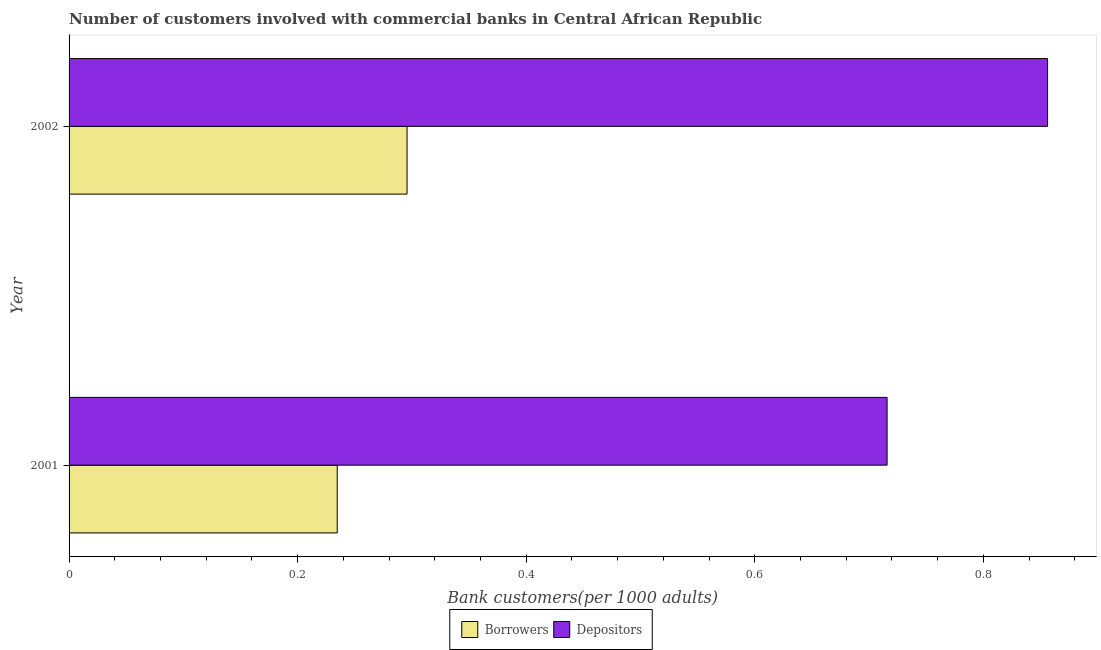Are the number of bars per tick equal to the number of legend labels?
Make the answer very short. Yes. How many bars are there on the 2nd tick from the bottom?
Ensure brevity in your answer.  2. What is the label of the 1st group of bars from the top?
Your response must be concise. 2002. What is the number of borrowers in 2002?
Make the answer very short. 0.3. Across all years, what is the maximum number of borrowers?
Your answer should be compact. 0.3. Across all years, what is the minimum number of depositors?
Ensure brevity in your answer.  0.72. In which year was the number of borrowers maximum?
Provide a succinct answer. 2002. What is the total number of depositors in the graph?
Your answer should be compact. 1.57. What is the difference between the number of borrowers in 2001 and that in 2002?
Offer a very short reply. -0.06. What is the difference between the number of depositors in 2002 and the number of borrowers in 2001?
Your answer should be very brief. 0.62. What is the average number of depositors per year?
Offer a terse response. 0.79. In the year 2001, what is the difference between the number of depositors and number of borrowers?
Give a very brief answer. 0.48. What is the ratio of the number of borrowers in 2001 to that in 2002?
Provide a succinct answer. 0.79. In how many years, is the number of depositors greater than the average number of depositors taken over all years?
Offer a very short reply. 1. What does the 1st bar from the top in 2002 represents?
Offer a very short reply. Depositors. What does the 2nd bar from the bottom in 2002 represents?
Ensure brevity in your answer.  Depositors. How many bars are there?
Your answer should be compact. 4. Are all the bars in the graph horizontal?
Offer a very short reply. Yes. Does the graph contain any zero values?
Offer a very short reply. No. Does the graph contain grids?
Ensure brevity in your answer.  No. Where does the legend appear in the graph?
Provide a succinct answer. Bottom center. How many legend labels are there?
Ensure brevity in your answer.  2. What is the title of the graph?
Provide a succinct answer. Number of customers involved with commercial banks in Central African Republic. What is the label or title of the X-axis?
Provide a short and direct response. Bank customers(per 1000 adults). What is the label or title of the Y-axis?
Provide a short and direct response. Year. What is the Bank customers(per 1000 adults) in Borrowers in 2001?
Ensure brevity in your answer.  0.23. What is the Bank customers(per 1000 adults) in Depositors in 2001?
Provide a short and direct response. 0.72. What is the Bank customers(per 1000 adults) in Borrowers in 2002?
Your response must be concise. 0.3. What is the Bank customers(per 1000 adults) of Depositors in 2002?
Provide a succinct answer. 0.86. Across all years, what is the maximum Bank customers(per 1000 adults) in Borrowers?
Your response must be concise. 0.3. Across all years, what is the maximum Bank customers(per 1000 adults) in Depositors?
Your answer should be compact. 0.86. Across all years, what is the minimum Bank customers(per 1000 adults) in Borrowers?
Keep it short and to the point. 0.23. Across all years, what is the minimum Bank customers(per 1000 adults) in Depositors?
Keep it short and to the point. 0.72. What is the total Bank customers(per 1000 adults) in Borrowers in the graph?
Give a very brief answer. 0.53. What is the total Bank customers(per 1000 adults) in Depositors in the graph?
Offer a terse response. 1.57. What is the difference between the Bank customers(per 1000 adults) of Borrowers in 2001 and that in 2002?
Provide a short and direct response. -0.06. What is the difference between the Bank customers(per 1000 adults) in Depositors in 2001 and that in 2002?
Provide a short and direct response. -0.14. What is the difference between the Bank customers(per 1000 adults) of Borrowers in 2001 and the Bank customers(per 1000 adults) of Depositors in 2002?
Make the answer very short. -0.62. What is the average Bank customers(per 1000 adults) in Borrowers per year?
Your response must be concise. 0.27. What is the average Bank customers(per 1000 adults) in Depositors per year?
Your answer should be very brief. 0.79. In the year 2001, what is the difference between the Bank customers(per 1000 adults) of Borrowers and Bank customers(per 1000 adults) of Depositors?
Offer a very short reply. -0.48. In the year 2002, what is the difference between the Bank customers(per 1000 adults) of Borrowers and Bank customers(per 1000 adults) of Depositors?
Your response must be concise. -0.56. What is the ratio of the Bank customers(per 1000 adults) of Borrowers in 2001 to that in 2002?
Provide a succinct answer. 0.79. What is the ratio of the Bank customers(per 1000 adults) in Depositors in 2001 to that in 2002?
Provide a short and direct response. 0.84. What is the difference between the highest and the second highest Bank customers(per 1000 adults) in Borrowers?
Your answer should be very brief. 0.06. What is the difference between the highest and the second highest Bank customers(per 1000 adults) of Depositors?
Offer a very short reply. 0.14. What is the difference between the highest and the lowest Bank customers(per 1000 adults) in Borrowers?
Your answer should be compact. 0.06. What is the difference between the highest and the lowest Bank customers(per 1000 adults) of Depositors?
Your response must be concise. 0.14. 